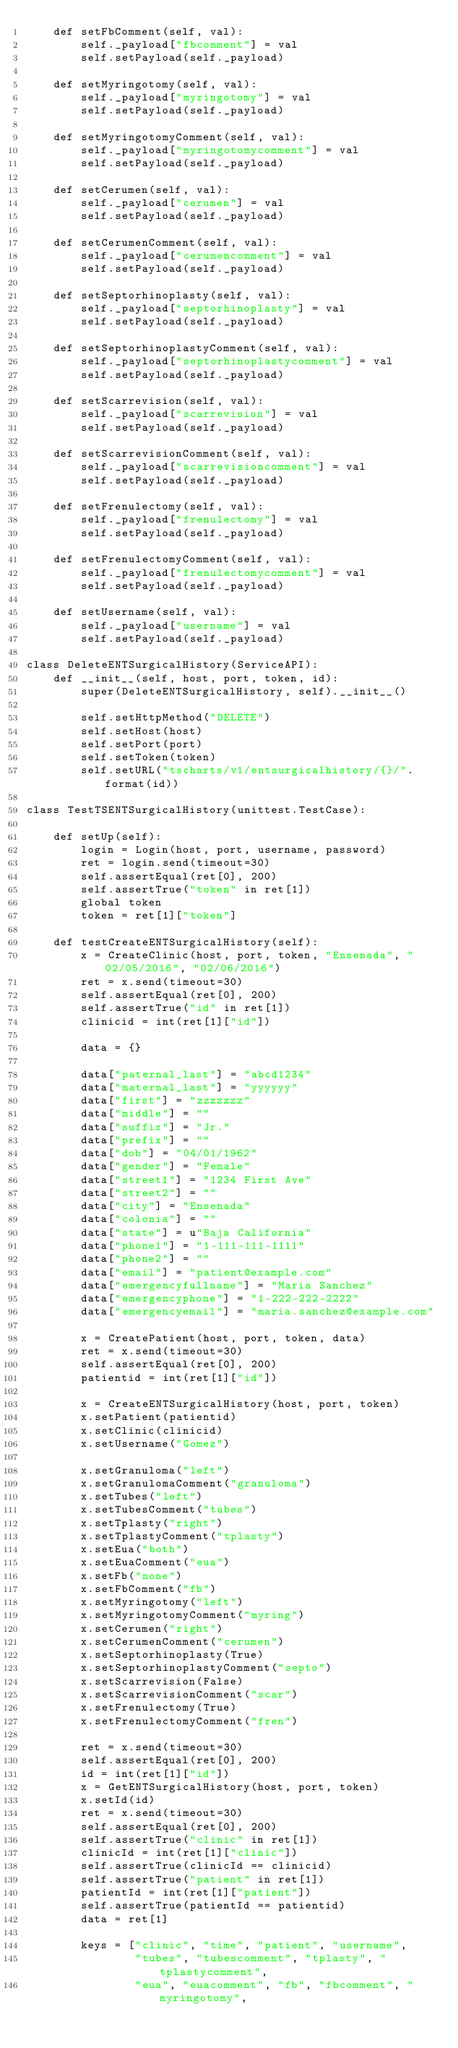<code> <loc_0><loc_0><loc_500><loc_500><_Python_>    def setFbComment(self, val):
        self._payload["fbcomment"] = val 
        self.setPayload(self._payload)
    
    def setMyringotomy(self, val):
        self._payload["myringotomy"] = val 
        self.setPayload(self._payload)
    
    def setMyringotomyComment(self, val):
        self._payload["myringotomycomment"] = val 
        self.setPayload(self._payload)
    
    def setCerumen(self, val):
        self._payload["cerumen"] = val 
        self.setPayload(self._payload)
    
    def setCerumenComment(self, val):
        self._payload["cerumencomment"] = val 
        self.setPayload(self._payload)
    
    def setSeptorhinoplasty(self, val):
        self._payload["septorhinoplasty"] = val 
        self.setPayload(self._payload)
    
    def setSeptorhinoplastyComment(self, val):
        self._payload["septorhinoplastycomment"] = val 
        self.setPayload(self._payload)
    
    def setScarrevision(self, val):
        self._payload["scarrevision"] = val 
        self.setPayload(self._payload)
    
    def setScarrevisionComment(self, val):
        self._payload["scarrevisioncomment"] = val 
        self.setPayload(self._payload)
    
    def setFrenulectomy(self, val):
        self._payload["frenulectomy"] = val 
        self.setPayload(self._payload)
    
    def setFrenulectomyComment(self, val):
        self._payload["frenulectomycomment"] = val 
        self.setPayload(self._payload)
    
    def setUsername(self, val):
        self._payload["username"] = val 
        self.setPayload(self._payload)
    
class DeleteENTSurgicalHistory(ServiceAPI):
    def __init__(self, host, port, token, id):
        super(DeleteENTSurgicalHistory, self).__init__()
        
        self.setHttpMethod("DELETE")
        self.setHost(host)
        self.setPort(port)
        self.setToken(token)
        self.setURL("tscharts/v1/entsurgicalhistory/{}/".format(id))

class TestTSENTSurgicalHistory(unittest.TestCase):

    def setUp(self):
        login = Login(host, port, username, password)
        ret = login.send(timeout=30)
        self.assertEqual(ret[0], 200)
        self.assertTrue("token" in ret[1])
        global token
        token = ret[1]["token"]

    def testCreateENTSurgicalHistory(self):
        x = CreateClinic(host, port, token, "Ensenada", "02/05/2016", "02/06/2016")
        ret = x.send(timeout=30)
        self.assertEqual(ret[0], 200)
        self.assertTrue("id" in ret[1])
        clinicid = int(ret[1]["id"])

        data = {}

        data["paternal_last"] = "abcd1234"
        data["maternal_last"] = "yyyyyy"
        data["first"] = "zzzzzzz"
        data["middle"] = ""
        data["suffix"] = "Jr."
        data["prefix"] = ""
        data["dob"] = "04/01/1962"
        data["gender"] = "Female"
        data["street1"] = "1234 First Ave"
        data["street2"] = ""
        data["city"] = "Ensenada"
        data["colonia"] = ""
        data["state"] = u"Baja California"
        data["phone1"] = "1-111-111-1111"
        data["phone2"] = ""
        data["email"] = "patient@example.com"
        data["emergencyfullname"] = "Maria Sanchez"
        data["emergencyphone"] = "1-222-222-2222"
        data["emergencyemail"] = "maria.sanchez@example.com"

        x = CreatePatient(host, port, token, data)
        ret = x.send(timeout=30)
        self.assertEqual(ret[0], 200)
        patientid = int(ret[1]["id"])

        x = CreateENTSurgicalHistory(host, port, token)
        x.setPatient(patientid)
        x.setClinic(clinicid)
        x.setUsername("Gomez")

        x.setGranuloma("left")
        x.setGranulomaComment("granuloma")
        x.setTubes("left")
        x.setTubesComment("tubes")
        x.setTplasty("right")
        x.setTplastyComment("tplasty")
        x.setEua("both")
        x.setEuaComment("eua")
        x.setFb("none")
        x.setFbComment("fb")
        x.setMyringotomy("left")
        x.setMyringotomyComment("myring")
        x.setCerumen("right")
        x.setCerumenComment("cerumen")
        x.setSeptorhinoplasty(True)
        x.setSeptorhinoplastyComment("septo")
        x.setScarrevision(False)
        x.setScarrevisionComment("scar")
        x.setFrenulectomy(True)
        x.setFrenulectomyComment("fren")
       
        ret = x.send(timeout=30)
        self.assertEqual(ret[0], 200)
        id = int(ret[1]["id"])
        x = GetENTSurgicalHistory(host, port, token)
        x.setId(id)
        ret = x.send(timeout=30)
        self.assertEqual(ret[0], 200)  
        self.assertTrue("clinic" in ret[1])
        clinicId = int(ret[1]["clinic"])
        self.assertTrue(clinicId == clinicid)
        self.assertTrue("patient" in ret[1])
        patientId = int(ret[1]["patient"])
        self.assertTrue(patientId == patientid)
        data = ret[1]

        keys = ["clinic", "time", "patient", "username",
                "tubes", "tubescomment", "tplasty", "tplastycomment",
                "eua", "euacomment", "fb", "fbcomment", "myringotomy",</code> 